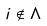<formula> <loc_0><loc_0><loc_500><loc_500>i \notin \Lambda</formula> 